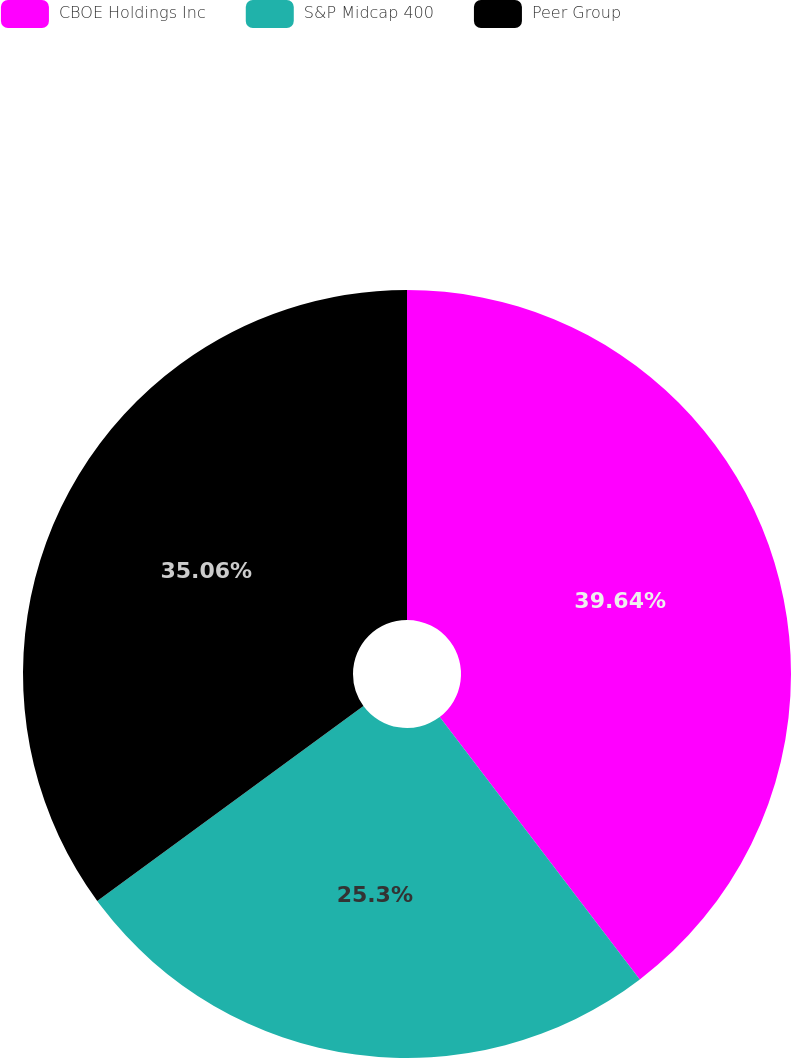Convert chart to OTSL. <chart><loc_0><loc_0><loc_500><loc_500><pie_chart><fcel>CBOE Holdings Inc<fcel>S&P Midcap 400<fcel>Peer Group<nl><fcel>39.63%<fcel>25.3%<fcel>35.06%<nl></chart> 